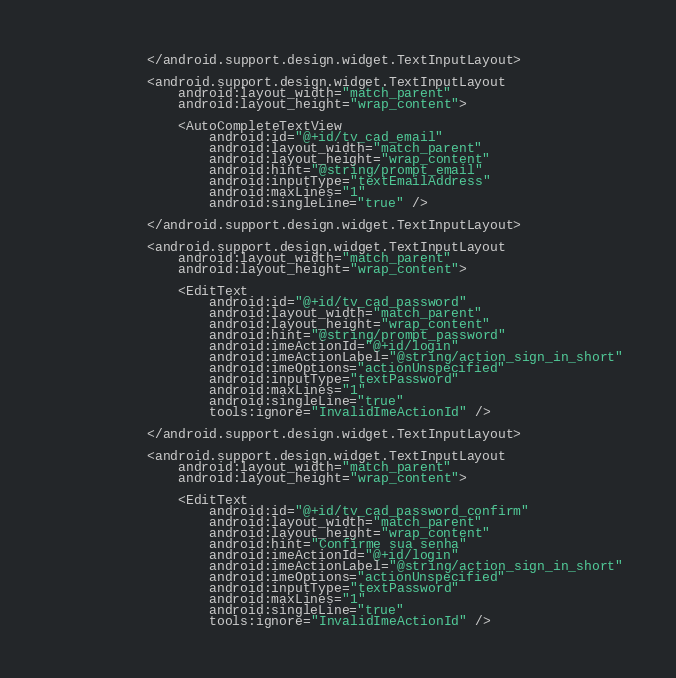<code> <loc_0><loc_0><loc_500><loc_500><_XML_>            </android.support.design.widget.TextInputLayout>

            <android.support.design.widget.TextInputLayout
                android:layout_width="match_parent"
                android:layout_height="wrap_content">

                <AutoCompleteTextView
                    android:id="@+id/tv_cad_email"
                    android:layout_width="match_parent"
                    android:layout_height="wrap_content"
                    android:hint="@string/prompt_email"
                    android:inputType="textEmailAddress"
                    android:maxLines="1"
                    android:singleLine="true" />

            </android.support.design.widget.TextInputLayout>

            <android.support.design.widget.TextInputLayout
                android:layout_width="match_parent"
                android:layout_height="wrap_content">

                <EditText
                    android:id="@+id/tv_cad_password"
                    android:layout_width="match_parent"
                    android:layout_height="wrap_content"
                    android:hint="@string/prompt_password"
                    android:imeActionId="@+id/login"
                    android:imeActionLabel="@string/action_sign_in_short"
                    android:imeOptions="actionUnspecified"
                    android:inputType="textPassword"
                    android:maxLines="1"
                    android:singleLine="true"
                    tools:ignore="InvalidImeActionId" />

            </android.support.design.widget.TextInputLayout>

            <android.support.design.widget.TextInputLayout
                android:layout_width="match_parent"
                android:layout_height="wrap_content">

                <EditText
                    android:id="@+id/tv_cad_password_confirm"
                    android:layout_width="match_parent"
                    android:layout_height="wrap_content"
                    android:hint="Confirme sua senha"
                    android:imeActionId="@+id/login"
                    android:imeActionLabel="@string/action_sign_in_short"
                    android:imeOptions="actionUnspecified"
                    android:inputType="textPassword"
                    android:maxLines="1"
                    android:singleLine="true"
                    tools:ignore="InvalidImeActionId" />
</code> 